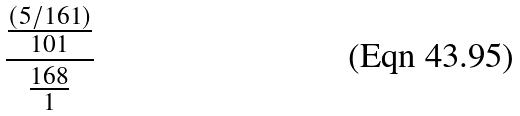Convert formula to latex. <formula><loc_0><loc_0><loc_500><loc_500>\frac { \frac { ( 5 / 1 6 1 ) } { 1 0 1 } } { \frac { 1 6 8 } { 1 } }</formula> 